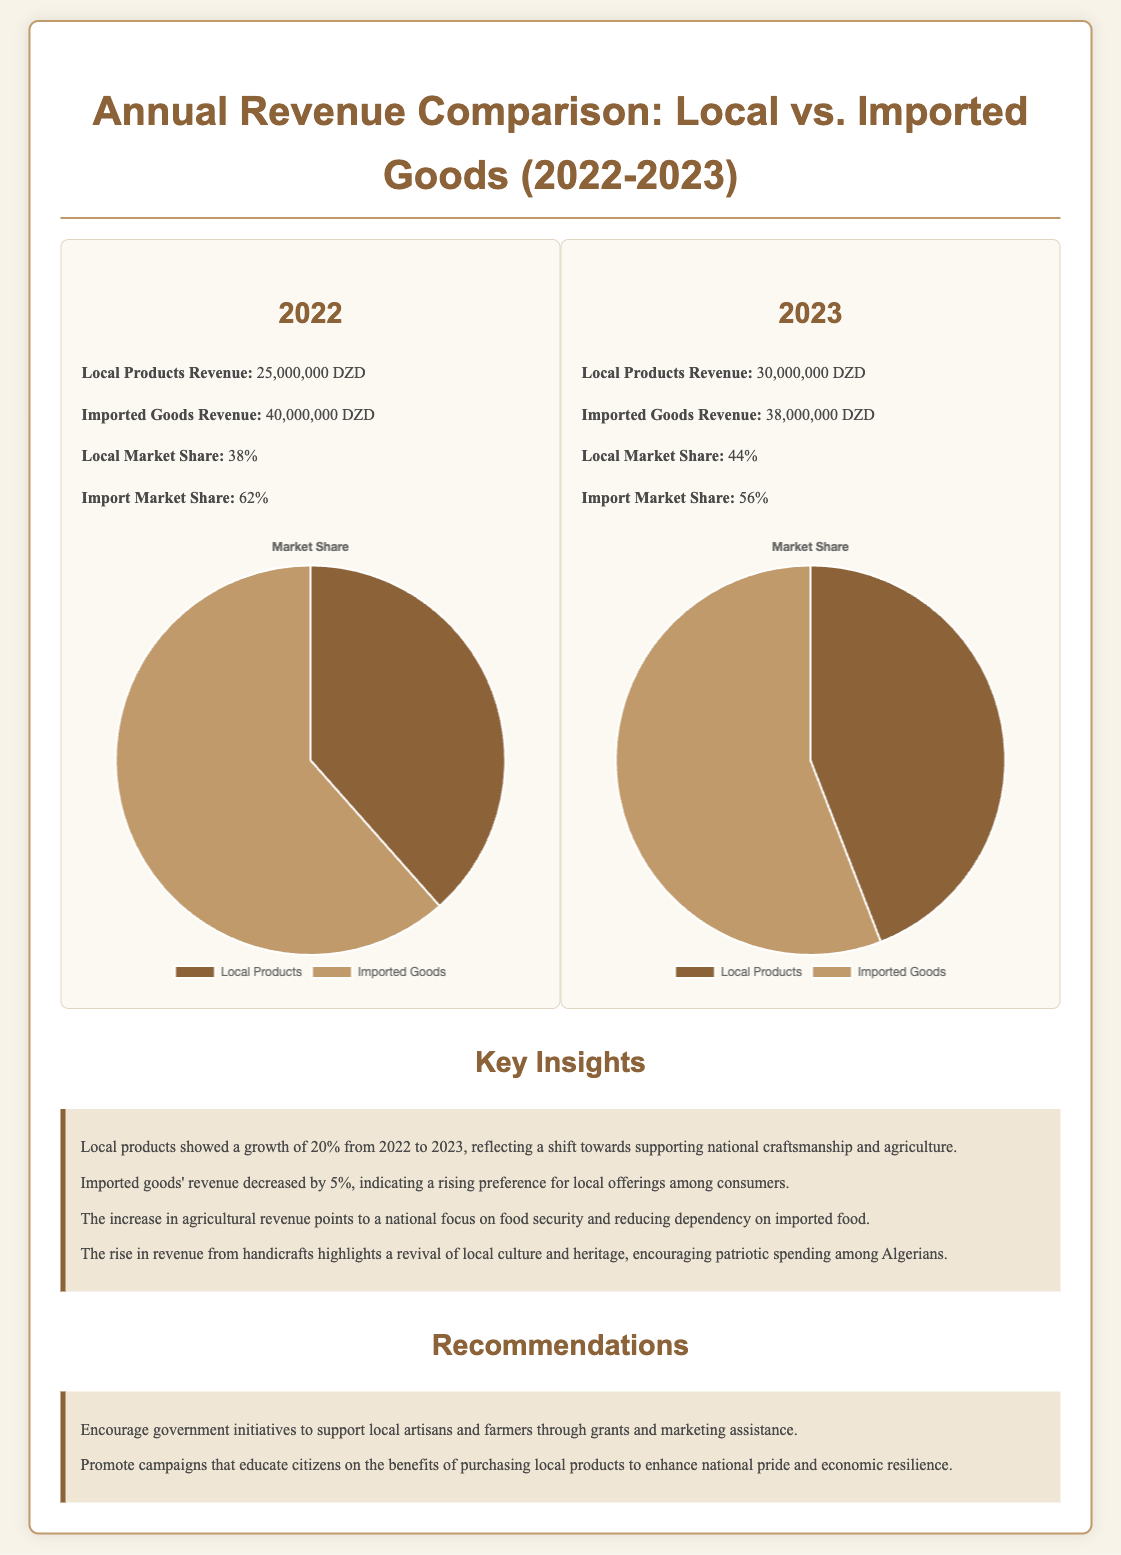What was the local products revenue in 2022? The document states that the local products revenue in 2022 was 25,000,000 DZD.
Answer: 25,000,000 DZD What was the imported goods revenue in 2023? According to the document, the imported goods revenue in 2023 was 38,000,000 DZD.
Answer: 38,000,000 DZD What was the percentage increase of local products revenue from 2022 to 2023? The document indicates a growth of 20% in local products revenue from 2022 to 2023.
Answer: 20% What is the local market share in 2023? The document mentions that the local market share in 2023 is 44%.
Answer: 44% What trend did the revenue from imported goods show from 2022 to 2023? The document reports a decrease in the revenue from imported goods by 5% from 2022 to 2023.
Answer: Decrease What does the growth of local products revenue reflect? The document reflects that the growth indicates a shift towards supporting national craftsmanship and agriculture.
Answer: Shift towards supporting national craftsmanship What is one of the recommendations provided in the report? According to the document, one recommendation is to encourage government initiatives to support local artisans and farmers.
Answer: Encourage government initiatives What does the increase in agricultural revenue point to? The document suggests that the increase in agricultural revenue points to a national focus on food security and reducing dependency on imported food.
Answer: National focus on food security What was the total local revenue in 2023? The document states that the local products revenue in 2023 was 30,000,000 DZD.
Answer: 30,000,000 DZD 